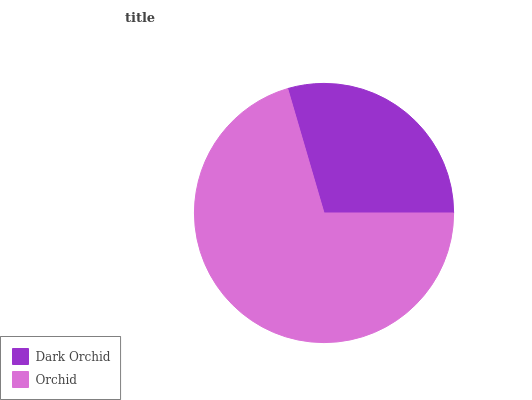Is Dark Orchid the minimum?
Answer yes or no. Yes. Is Orchid the maximum?
Answer yes or no. Yes. Is Orchid the minimum?
Answer yes or no. No. Is Orchid greater than Dark Orchid?
Answer yes or no. Yes. Is Dark Orchid less than Orchid?
Answer yes or no. Yes. Is Dark Orchid greater than Orchid?
Answer yes or no. No. Is Orchid less than Dark Orchid?
Answer yes or no. No. Is Orchid the high median?
Answer yes or no. Yes. Is Dark Orchid the low median?
Answer yes or no. Yes. Is Dark Orchid the high median?
Answer yes or no. No. Is Orchid the low median?
Answer yes or no. No. 